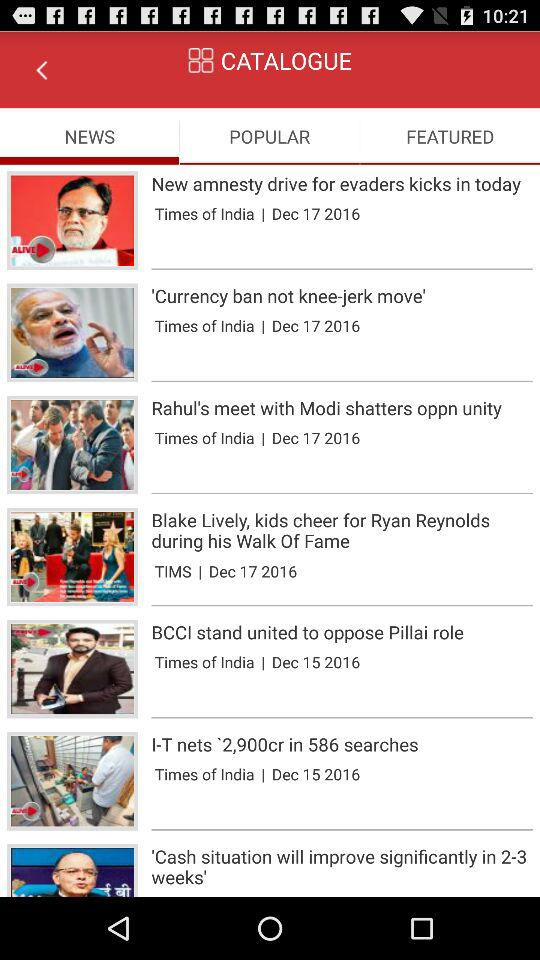When was the "BCCI stand united to oppose Pillai role" news published? It was published on December 15, 2016. 